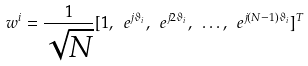Convert formula to latex. <formula><loc_0><loc_0><loc_500><loc_500>w ^ { i } = \frac { 1 } { \sqrt { N } } [ 1 , \ e ^ { j \vartheta _ { i } } , \ e ^ { j 2 \vartheta _ { i } } , \ \dots , \ e ^ { j ( N - 1 ) \vartheta _ { i } } ] ^ { T }</formula> 